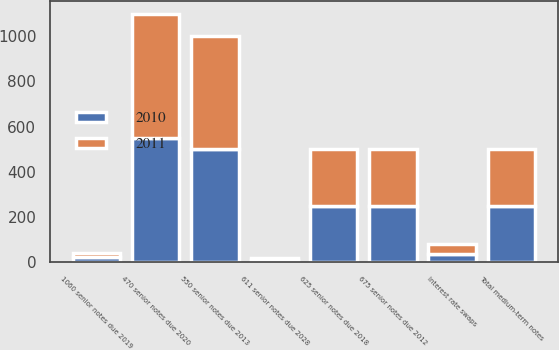Convert chart. <chart><loc_0><loc_0><loc_500><loc_500><stacked_bar_chart><ecel><fcel>675 senior notes due 2012<fcel>550 senior notes due 2013<fcel>625 senior notes due 2018<fcel>1060 senior notes due 2019<fcel>470 senior notes due 2020<fcel>611 senior notes due 2028<fcel>Interest rate swaps<fcel>Total medium-term notes<nl><fcel>2010<fcel>250<fcel>500<fcel>250<fcel>20.7<fcel>550<fcel>10<fcel>35.8<fcel>250<nl><fcel>2011<fcel>250<fcel>500<fcel>250<fcel>20.7<fcel>550<fcel>10<fcel>42.3<fcel>250<nl></chart> 